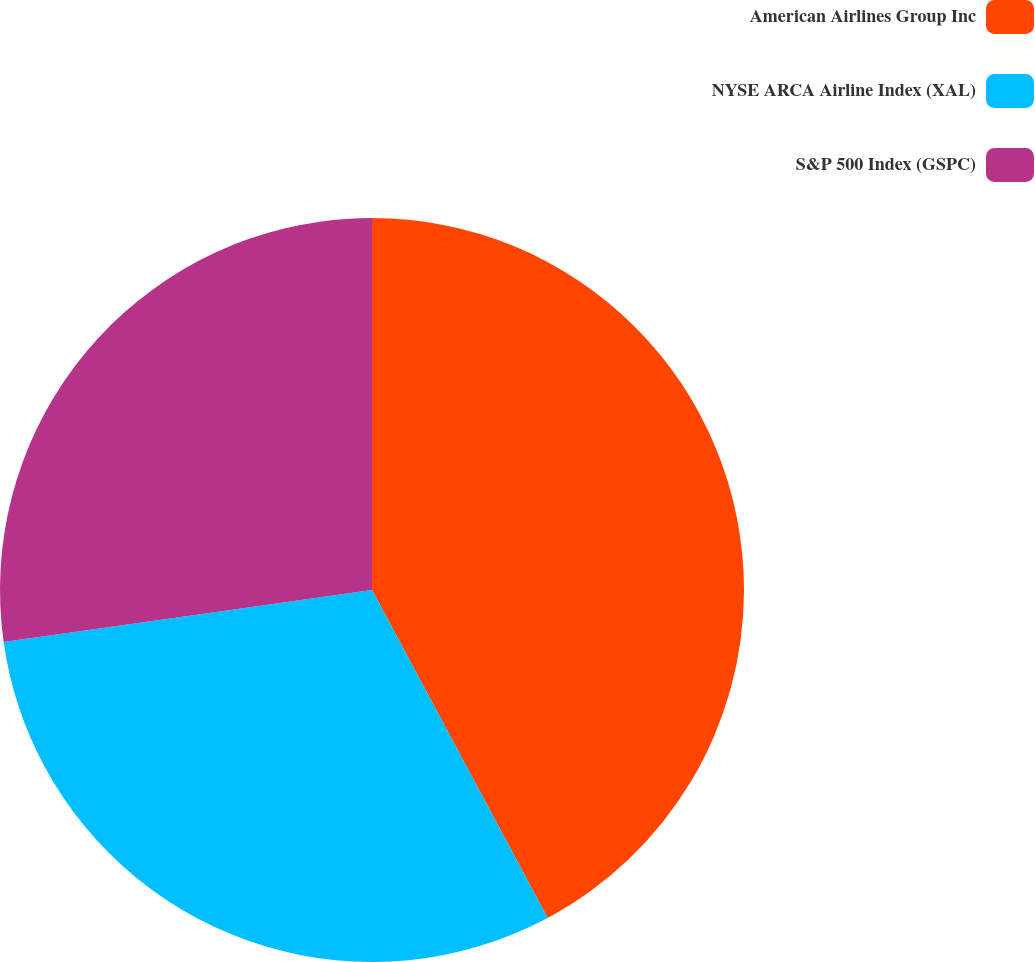Convert chart to OTSL. <chart><loc_0><loc_0><loc_500><loc_500><pie_chart><fcel>American Airlines Group Inc<fcel>NYSE ARCA Airline Index (XAL)<fcel>S&P 500 Index (GSPC)<nl><fcel>42.17%<fcel>30.6%<fcel>27.23%<nl></chart> 